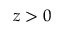<formula> <loc_0><loc_0><loc_500><loc_500>z > 0</formula> 